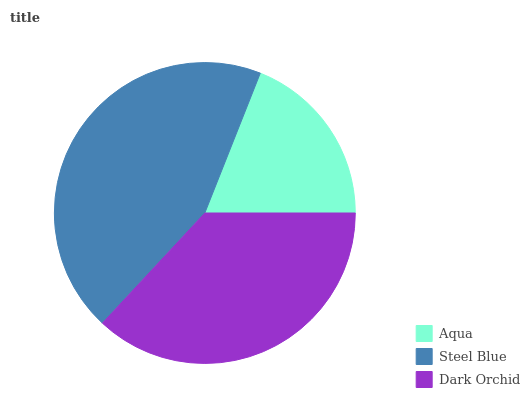Is Aqua the minimum?
Answer yes or no. Yes. Is Steel Blue the maximum?
Answer yes or no. Yes. Is Dark Orchid the minimum?
Answer yes or no. No. Is Dark Orchid the maximum?
Answer yes or no. No. Is Steel Blue greater than Dark Orchid?
Answer yes or no. Yes. Is Dark Orchid less than Steel Blue?
Answer yes or no. Yes. Is Dark Orchid greater than Steel Blue?
Answer yes or no. No. Is Steel Blue less than Dark Orchid?
Answer yes or no. No. Is Dark Orchid the high median?
Answer yes or no. Yes. Is Dark Orchid the low median?
Answer yes or no. Yes. Is Steel Blue the high median?
Answer yes or no. No. Is Steel Blue the low median?
Answer yes or no. No. 